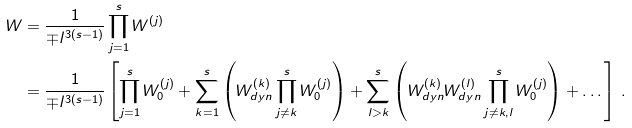Convert formula to latex. <formula><loc_0><loc_0><loc_500><loc_500>W & = \frac { 1 } { \mp l ^ { 3 ( s - 1 ) } } \prod _ { j = 1 } ^ { s } W ^ { ( j ) } \\ & = \frac { 1 } { \mp l ^ { 3 ( s - 1 ) } } \left [ \prod _ { j = 1 } ^ { s } W _ { 0 } ^ { ( j ) } + \sum _ { k = 1 } ^ { s } \left ( W _ { d y n } ^ { ( k ) } \prod _ { j \neq k } ^ { s } W _ { 0 } ^ { ( j ) } \right ) + \sum _ { l > k } ^ { s } \left ( W _ { d y n } ^ { ( k ) } W _ { d y n } ^ { ( l ) } \prod _ { j \neq k , l } ^ { s } W _ { 0 } ^ { ( j ) } \right ) + \dots \right ] \, .</formula> 